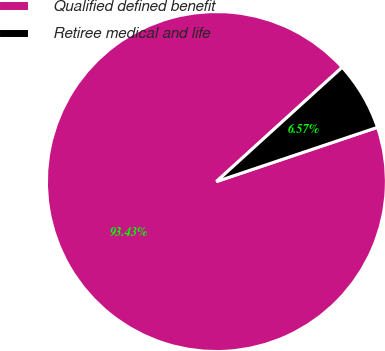<chart> <loc_0><loc_0><loc_500><loc_500><pie_chart><fcel>Qualified defined benefit<fcel>Retiree medical and life<nl><fcel>93.43%<fcel>6.57%<nl></chart> 